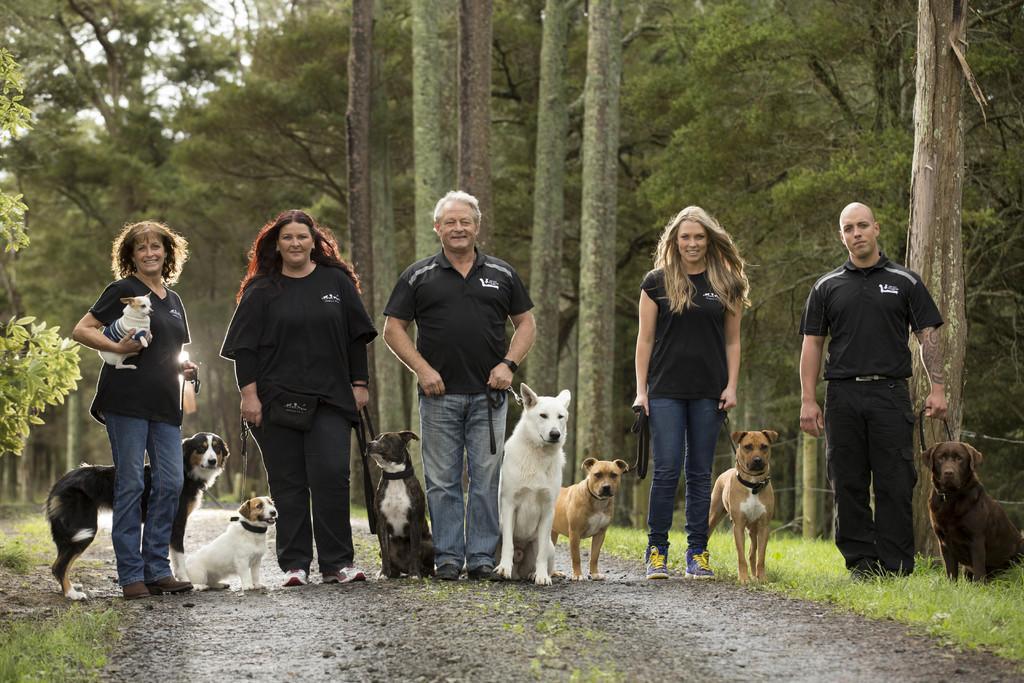Can you describe this image briefly? In this image we can see people standing and there are dogs. On the left there is a lady holding a dog. In the background there are trees. At the bottom there is grass. 